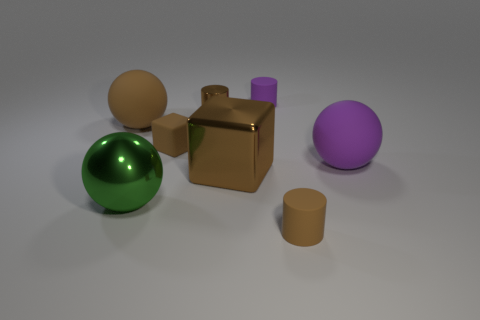Subtract all blue spheres. How many brown cylinders are left? 2 Add 1 yellow balls. How many objects exist? 9 Subtract all cylinders. How many objects are left? 5 Add 4 big purple matte spheres. How many big purple matte spheres are left? 5 Add 2 rubber things. How many rubber things exist? 7 Subtract 1 brown blocks. How many objects are left? 7 Subtract all large brown matte balls. Subtract all small purple metal blocks. How many objects are left? 7 